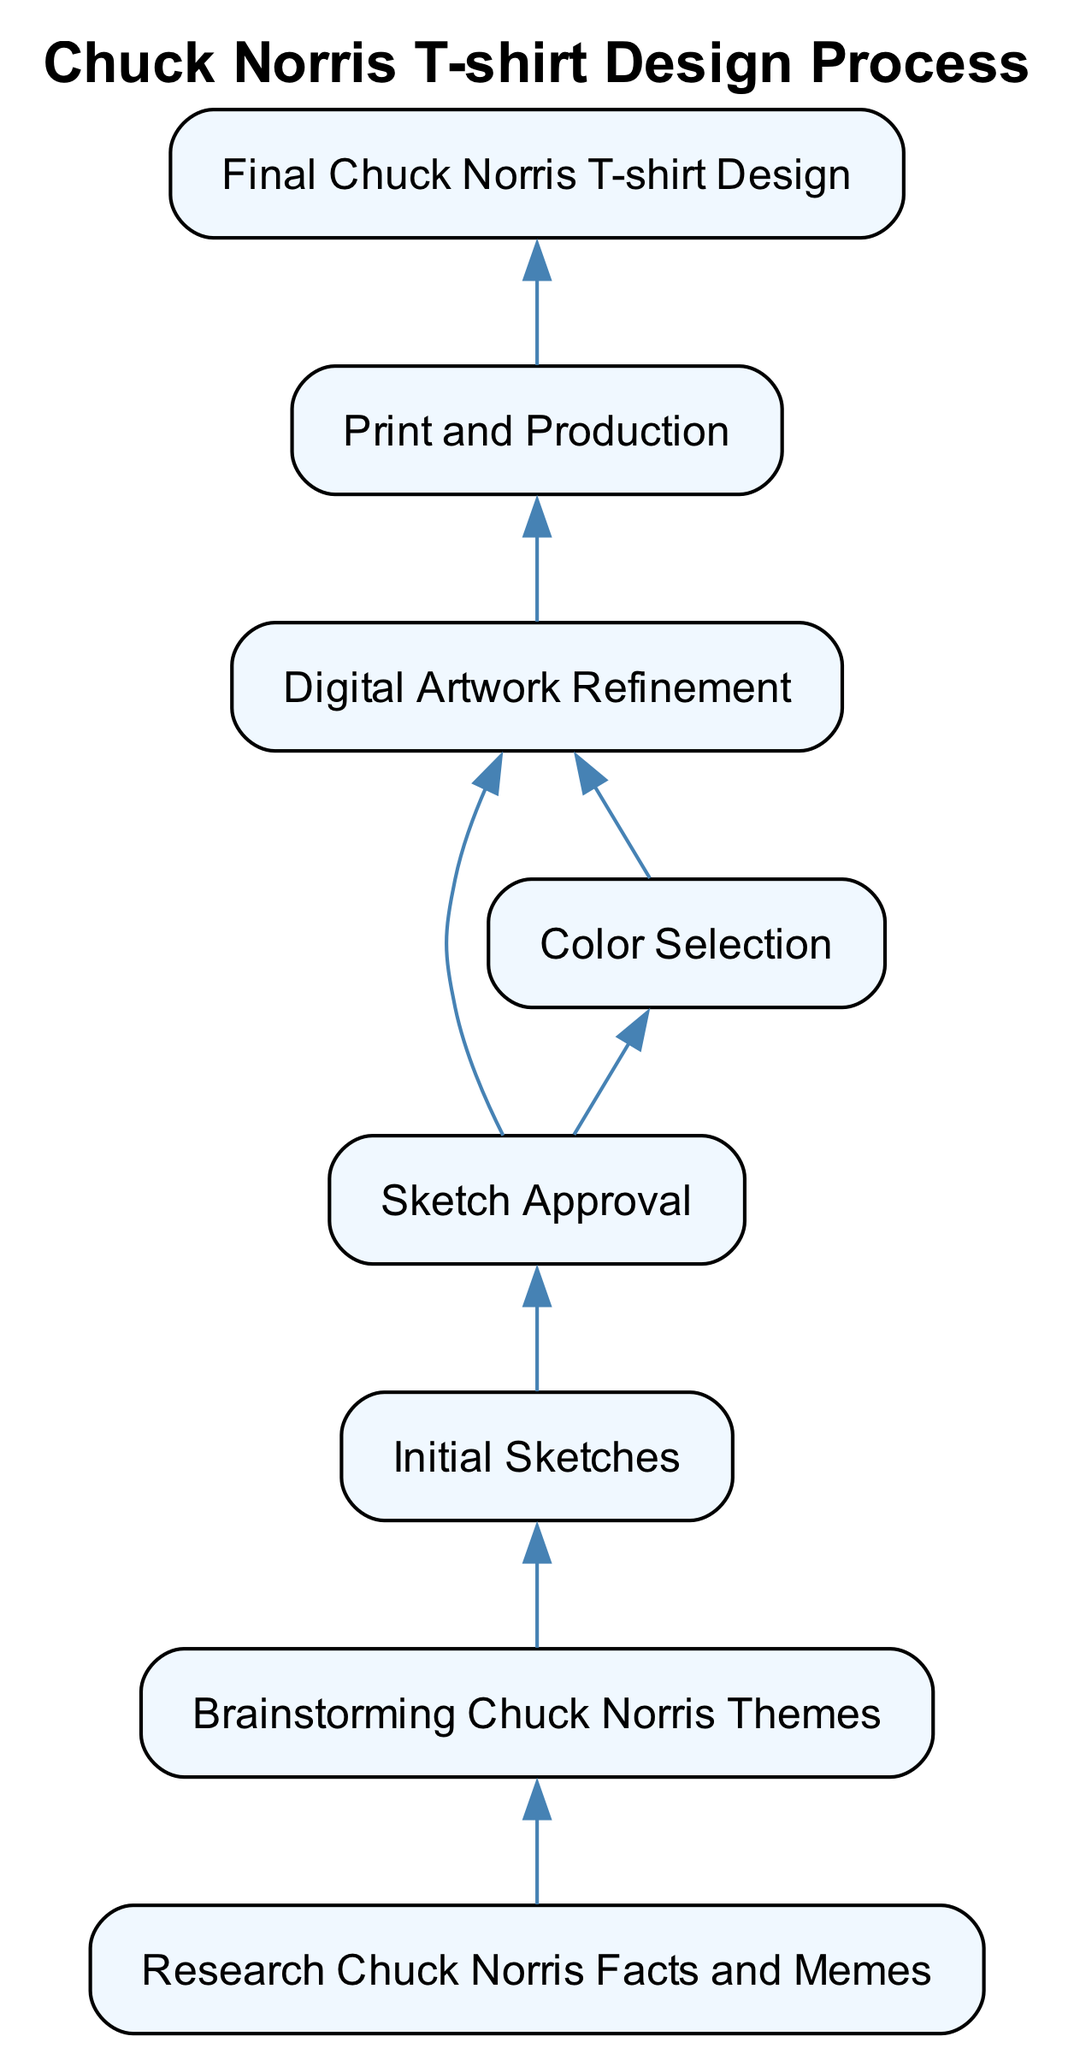What is the final output of the design process? The diagram indicates that the final output of the design process is represented by the node labeled "Final Chuck Norris T-shirt Design."
Answer: Final Chuck Norris T-shirt Design How many nodes are there in the diagram? The nodes in the diagram are: "Final Chuck Norris T-shirt Design," "Print and Production," "Digital Artwork Refinement," "Color Selection," "Sketch Approval," "Initial Sketches," "Brainstorming Chuck Norris Themes," and "Research Chuck Norris Facts and Memes." Counting these gives a total of eight nodes.
Answer: 8 What is the first step in the design process? The diagram shows that the first step in the design process is labeled "Research Chuck Norris Facts and Memes." This step starts the flow of the diagram.
Answer: Research Chuck Norris Facts and Memes Which node comes directly before "Color Selection"? The connection in the diagram shows that "Sketch Approval" comes directly before "Color Selection," as there is an edge pointing from "Sketch Approval" to "Color Selection."
Answer: Sketch Approval What is the relationship between "Digital Artwork Refinement" and "Print and Production"? The diagram indicates that "Digital Artwork Refinement" is directly connected to "Print and Production," with a directed edge flowing from the former to the latter, meaning that "Digital Artwork Refinement" must be completed before moving to "Print and Production."
Answer: Directly connected Which step requires approval before moving on to color selection? The diagram specifies that "Sketch Approval" is required before proceeding to "Color Selection," as indicated by the directed edge connecting these two nodes.
Answer: Sketch Approval How many edges are present in the diagram? The connections outlined in the diagram show the following edges: from "Research Chuck Norris Facts and Memes" to "Brainstorming Chuck Norris Themes," "Brainstorming Chuck Norris Themes" to "Initial Sketches," "Initial Sketches" to "Sketch Approval," "Sketch Approval" to both "Color Selection" and "Digital Artwork Refinement," "Color Selection" to "Digital Artwork Refinement," "Digital Artwork Refinement" to "Print and Production," and "Print and Production" to "Final Chuck Norris T-shirt Design." Counting these connections gives a total of seven edges.
Answer: 7 What does the edge from "Digital Artwork Refinement" lead to? Following the diagram, the edge from "Digital Artwork Refinement" leads directly to "Print and Production," indicating that once the digital artwork is refined, it progresses to the print stage of the process.
Answer: Print and Production 